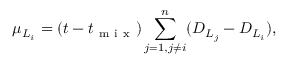Convert formula to latex. <formula><loc_0><loc_0><loc_500><loc_500>\mu _ { L _ { i } } = ( t - t _ { m i x } ) \sum _ { j = 1 , j \neq i } ^ { n } ( D _ { L _ { j } } - D _ { L _ { i } } ) ,</formula> 